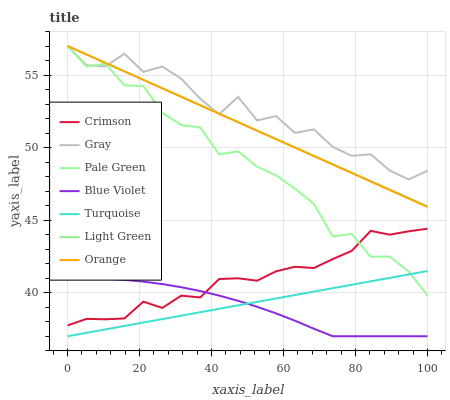Does Blue Violet have the minimum area under the curve?
Answer yes or no. Yes. Does Gray have the maximum area under the curve?
Answer yes or no. Yes. Does Turquoise have the minimum area under the curve?
Answer yes or no. No. Does Turquoise have the maximum area under the curve?
Answer yes or no. No. Is Orange the smoothest?
Answer yes or no. Yes. Is Gray the roughest?
Answer yes or no. Yes. Is Turquoise the smoothest?
Answer yes or no. No. Is Turquoise the roughest?
Answer yes or no. No. Does Turquoise have the lowest value?
Answer yes or no. Yes. Does Orange have the lowest value?
Answer yes or no. No. Does Light Green have the highest value?
Answer yes or no. Yes. Does Turquoise have the highest value?
Answer yes or no. No. Is Turquoise less than Light Green?
Answer yes or no. Yes. Is Gray greater than Blue Violet?
Answer yes or no. Yes. Does Pale Green intersect Turquoise?
Answer yes or no. Yes. Is Pale Green less than Turquoise?
Answer yes or no. No. Is Pale Green greater than Turquoise?
Answer yes or no. No. Does Turquoise intersect Light Green?
Answer yes or no. No. 